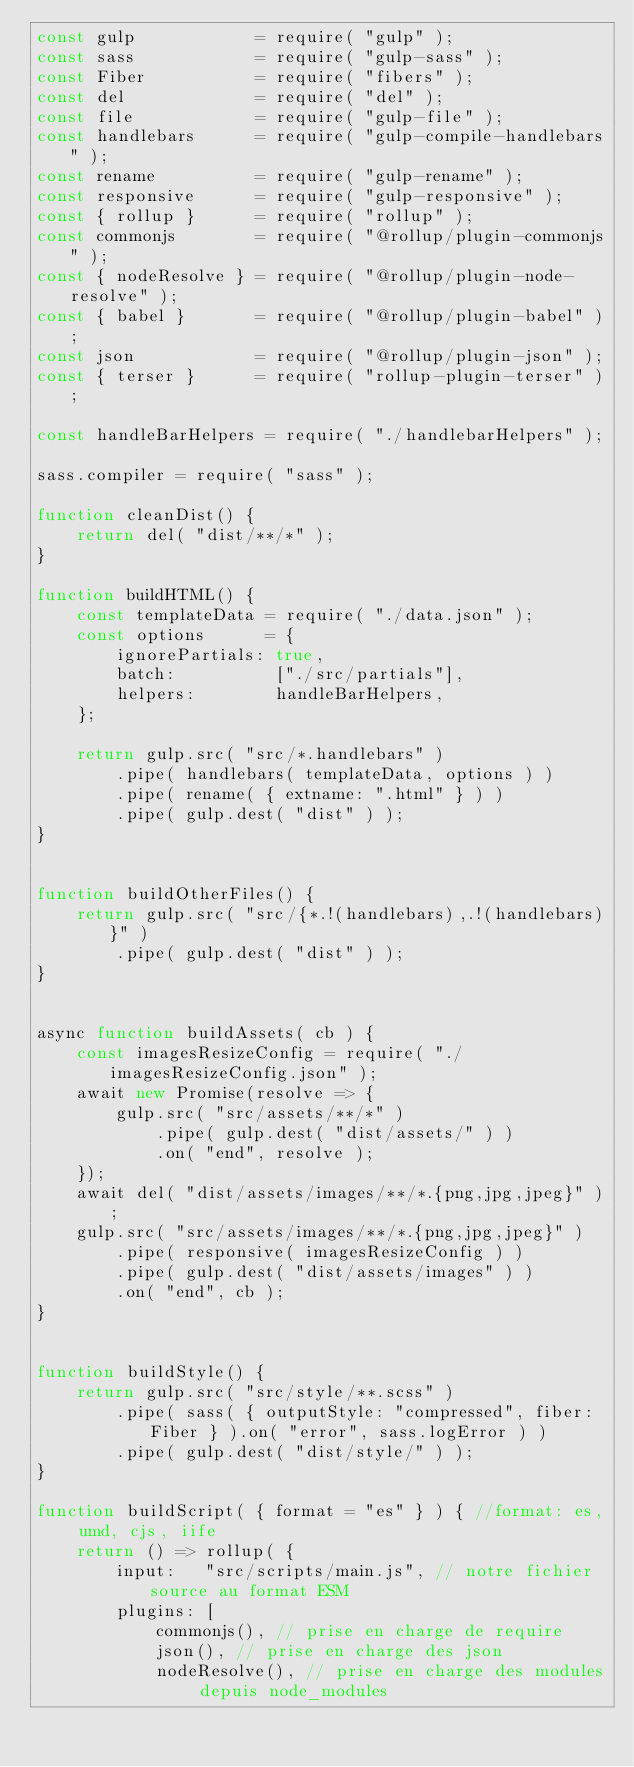Convert code to text. <code><loc_0><loc_0><loc_500><loc_500><_JavaScript_>const gulp            = require( "gulp" );
const sass            = require( "gulp-sass" );
const Fiber           = require( "fibers" );
const del             = require( "del" );
const file            = require( "gulp-file" );
const handlebars      = require( "gulp-compile-handlebars" );
const rename          = require( "gulp-rename" );
const responsive      = require( "gulp-responsive" );
const { rollup }      = require( "rollup" );
const commonjs        = require( "@rollup/plugin-commonjs" );
const { nodeResolve } = require( "@rollup/plugin-node-resolve" );
const { babel }       = require( "@rollup/plugin-babel" );
const json            = require( "@rollup/plugin-json" );
const { terser }      = require( "rollup-plugin-terser" );

const handleBarHelpers = require( "./handlebarHelpers" );

sass.compiler = require( "sass" );

function cleanDist() {
    return del( "dist/**/*" );
}

function buildHTML() {
    const templateData = require( "./data.json" );
    const options      = {
        ignorePartials: true,
        batch:          ["./src/partials"],
        helpers:        handleBarHelpers,
    };

    return gulp.src( "src/*.handlebars" )
        .pipe( handlebars( templateData, options ) )
        .pipe( rename( { extname: ".html" } ) )
        .pipe( gulp.dest( "dist" ) );
}


function buildOtherFiles() {
    return gulp.src( "src/{*.!(handlebars),.!(handlebars)}" )
        .pipe( gulp.dest( "dist" ) );
}


async function buildAssets( cb ) {
    const imagesResizeConfig = require( "./imagesResizeConfig.json" );
    await new Promise(resolve => {
        gulp.src( "src/assets/**/*" )
            .pipe( gulp.dest( "dist/assets/" ) )
            .on( "end", resolve );
    });
    await del( "dist/assets/images/**/*.{png,jpg,jpeg}" );
    gulp.src( "src/assets/images/**/*.{png,jpg,jpeg}" )
        .pipe( responsive( imagesResizeConfig ) )
        .pipe( gulp.dest( "dist/assets/images" ) )
        .on( "end", cb );
}


function buildStyle() {
    return gulp.src( "src/style/**.scss" )
        .pipe( sass( { outputStyle: "compressed", fiber: Fiber } ).on( "error", sass.logError ) )
        .pipe( gulp.dest( "dist/style/" ) );
}

function buildScript( { format = "es" } ) { //format: es, umd, cjs, iife
    return () => rollup( {
        input:   "src/scripts/main.js", // notre fichier source au format ESM
        plugins: [
            commonjs(), // prise en charge de require
            json(), // prise en charge des json
            nodeResolve(), // prise en charge des modules depuis node_modules</code> 